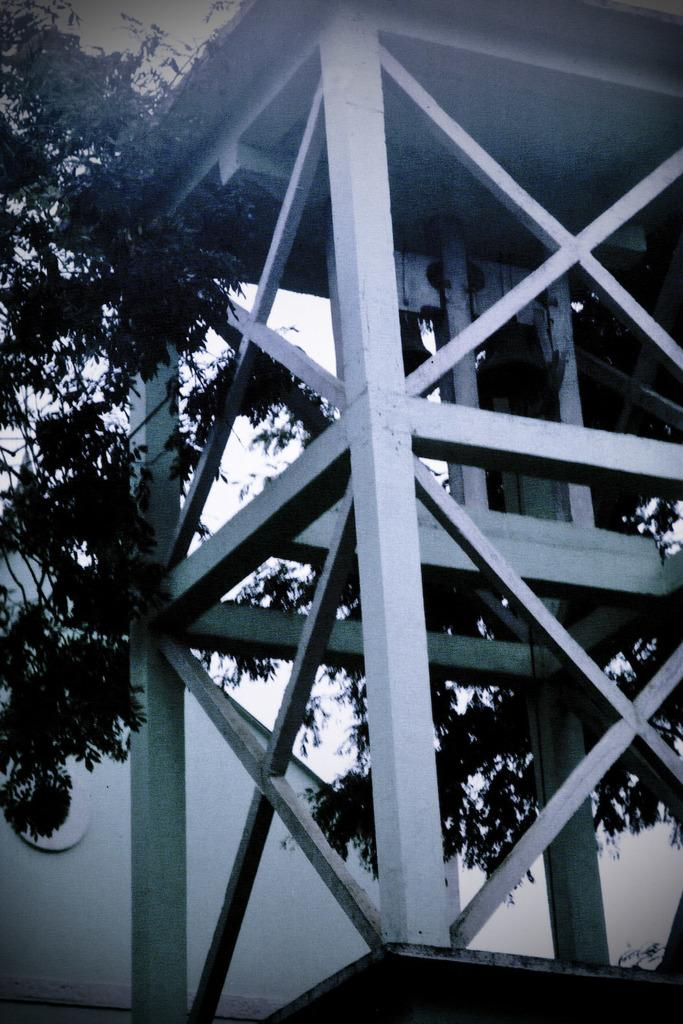What structure is located on the right side of the image? There is a tower on the right side of the image. What can be seen in the background of the image? There are trees and a wall in the background of the image. What is visible in the sky in the image? The sky is visible in the background of the image. How many ladybugs can be seen on the tower in the image? There are no ladybugs present in the image; it features a tower and trees in the background. What type of berry is growing on the wall in the image? There are no berries visible on the wall in the image. 